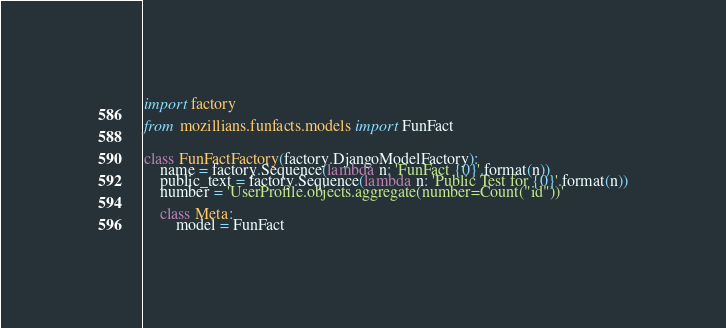Convert code to text. <code><loc_0><loc_0><loc_500><loc_500><_Python_>import factory

from mozillians.funfacts.models import FunFact


class FunFactFactory(factory.DjangoModelFactory):
    name = factory.Sequence(lambda n: 'FunFact {0}'.format(n))
    public_text = factory.Sequence(lambda n: 'Public Test for {0}'.format(n))
    number = 'UserProfile.objects.aggregate(number=Count("id"))'

    class Meta:
        model = FunFact
</code> 